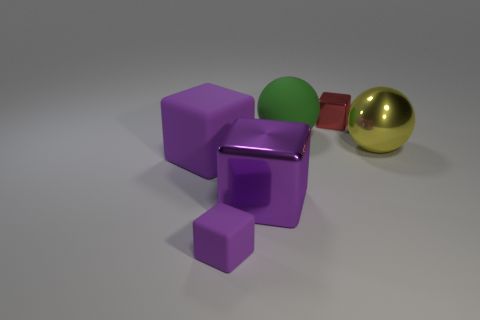How many purple blocks must be subtracted to get 1 purple blocks? 2 Subtract all green cylinders. How many purple blocks are left? 3 Subtract all small shiny blocks. How many blocks are left? 3 Add 4 big cyan rubber blocks. How many objects exist? 10 Subtract all red blocks. How many blocks are left? 3 Subtract all cyan cubes. Subtract all blue cylinders. How many cubes are left? 4 Add 4 tiny rubber things. How many tiny rubber things are left? 5 Add 4 yellow metallic things. How many yellow metallic things exist? 5 Subtract 1 yellow balls. How many objects are left? 5 Subtract all spheres. How many objects are left? 4 